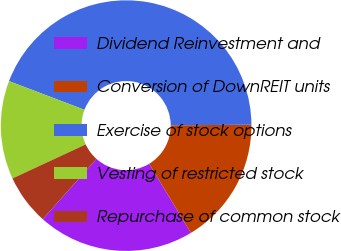Convert chart to OTSL. <chart><loc_0><loc_0><loc_500><loc_500><pie_chart><fcel>Dividend Reinvestment and<fcel>Conversion of DownREIT units<fcel>Exercise of stock options<fcel>Vesting of restricted stock<fcel>Repurchase of common stock<nl><fcel>20.23%<fcel>16.47%<fcel>44.11%<fcel>12.7%<fcel>6.49%<nl></chart> 